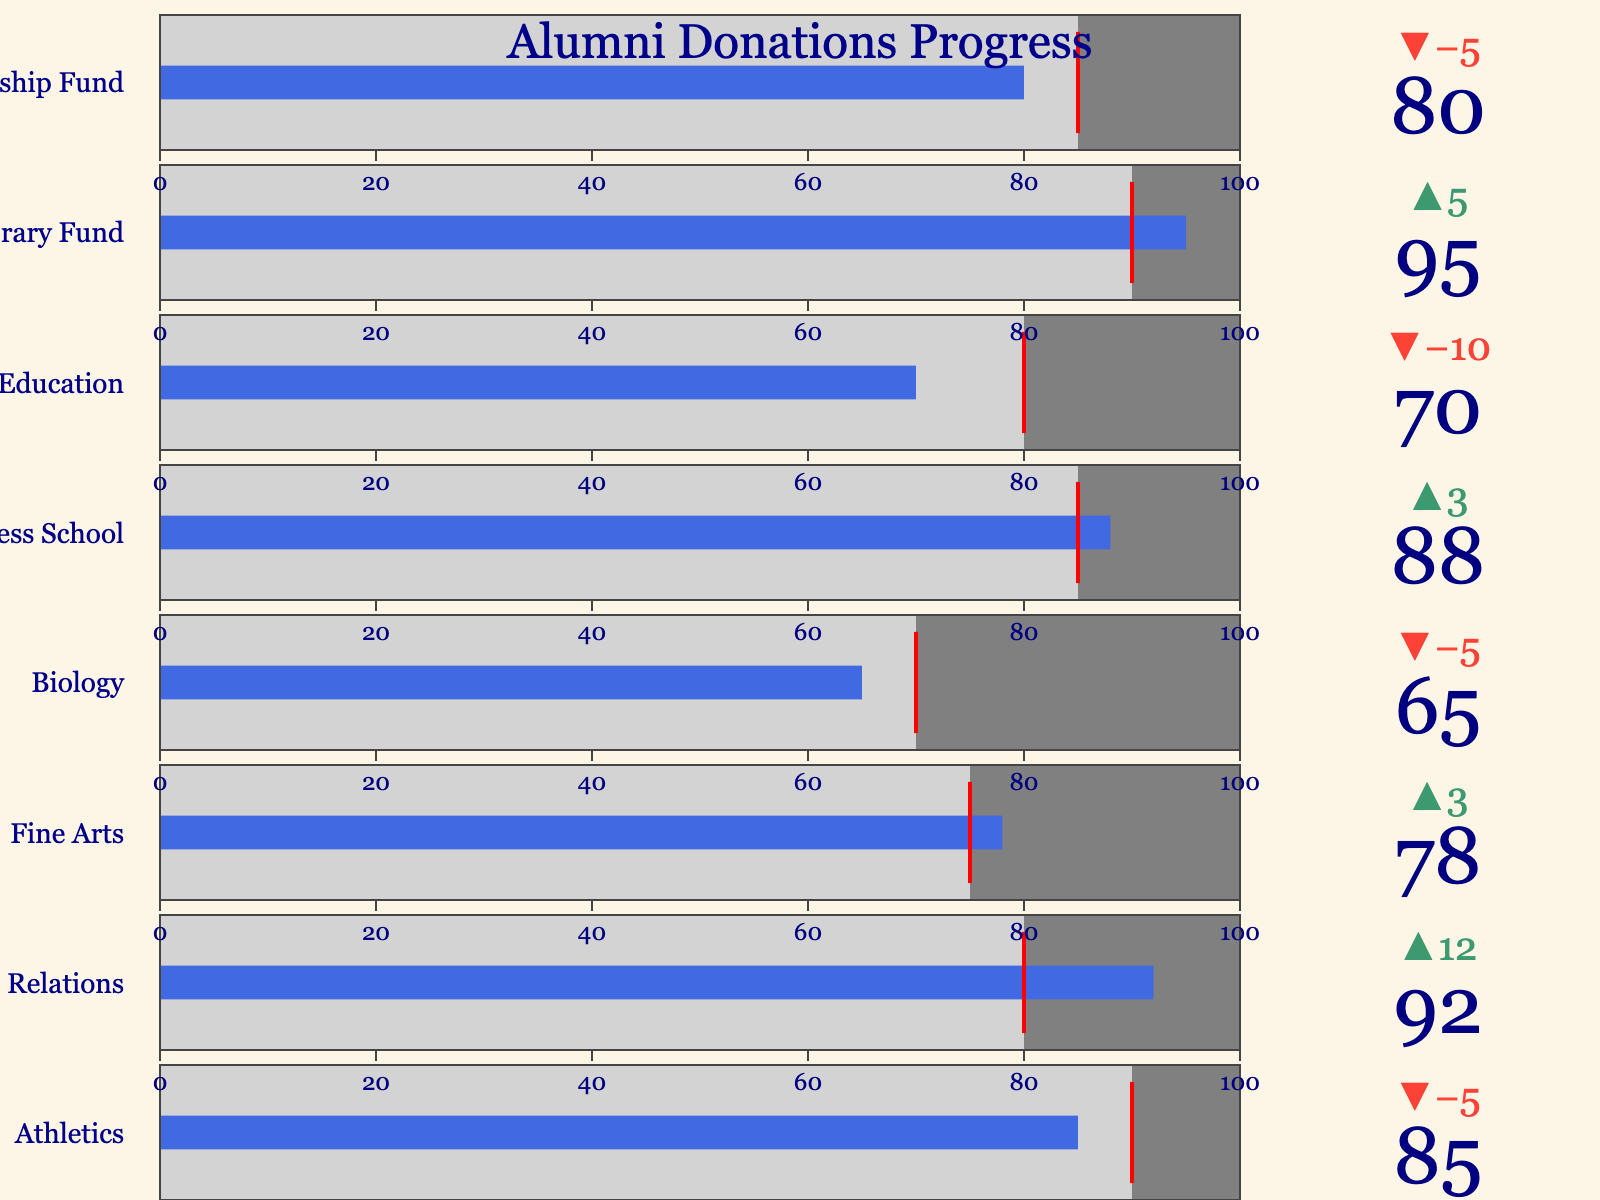What is the title of the figure? The title of the figure is displayed at the top center of the chart in large, dark blue text.
Answer: Alumni Donations Progress How many departments are represented in the figure? Count the number of distinct bullet charts, each representing a department.
Answer: 8 Which department exceeded its target by the largest margin? Compare the 'delta' values for each department, which indicate how much the actual donations surpassed the target.
Answer: Alumni Relations What color represents the actual donation amounts? Look at the bar color in each bullet chart that shows the actual donation amounts.
Answer: Royal blue Which department is closest to its target without exceeding it? Identify the department where the 'Actual' value is closest to, but does not surpass, the 'Target' value.
Answer: Athletics What is the total target amount for all departments combined? Sum up the 'Target' values for each department: 90 + 80 + 75 + 70 + 85 + 80 + 90 + 85.
Answer: 655 Which department has the lowest actual donation amount? Compare the 'Actual' values for each department to find the smallest one.
Answer: Biology How much more did the Library Fund receive compared to its target? Subtract the 'Target' value from the 'Actual' value for the Library Fund: 95 - 90.
Answer: 5 Are there any departments where the actual donation amount is exactly equal to the target? Check if the 'Actual' value matches the 'Target' value for any department.
Answer: No What is the average percentage of the actual donations compared to the targets across all departments? Calculate the percentage for each department, sum them up, and then divide by the number of departments: ((85/90)+(92/80)+(78/75)+(65/70)+(88/85)+(70/80)+(95/90)+(80/85))/8.
Answer: Approximately 1.01 